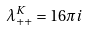Convert formula to latex. <formula><loc_0><loc_0><loc_500><loc_500>\lambda _ { + + } ^ { K } = 1 6 \pi i</formula> 